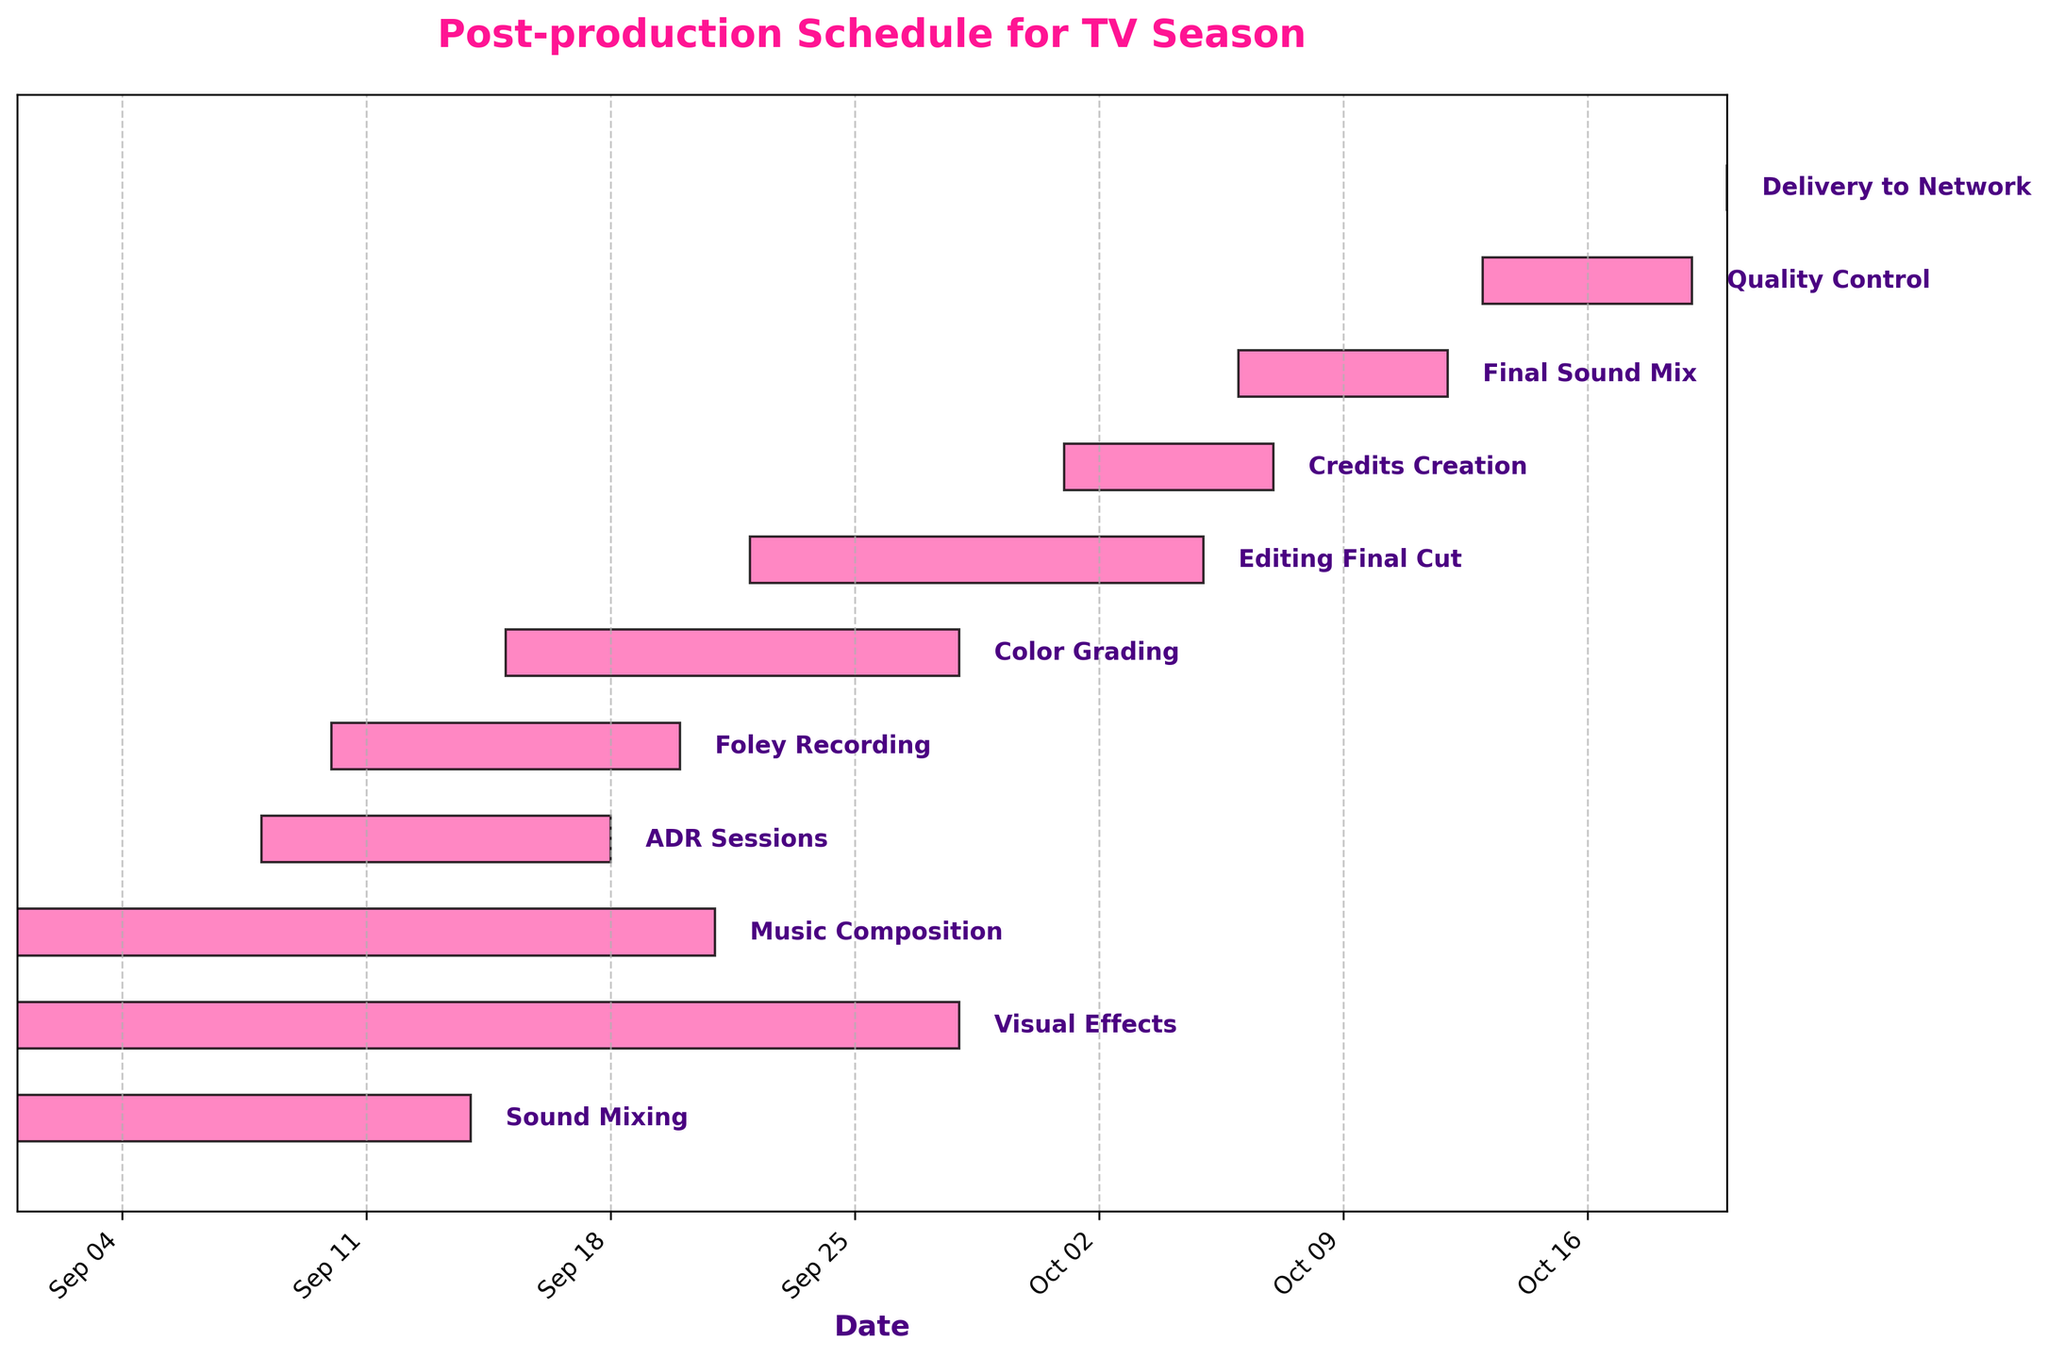What's the title of the Gantt chart? The title is often found at the top of the chart. In this case, it reads "Post-production Schedule for TV Season"
Answer: Post-production Schedule for TV Season What is the first task to start in the schedule? By examining the tasks and their respective start dates, we can see that "Sound Mixing," "Visual Effects," and "Music Composition" all begin on the earliest start date, which is 2023-09-01
Answer: Sound Mixing, Visual Effects, Music Composition Which task ends last in the schedule? To identify the task that ends last, we check the end dates for all tasks. The latest end date is 2023-10-20 for the "Delivery to Network" task
Answer: Delivery to Network What is the duration of the "Editing Final Cut" task? The duration of a task is calculated by the difference between its end date and start date. For "Editing Final Cut," it starts on 2023-09-22 and ends on 2023-10-05. The duration is (2023-10-05 - 2023-09-22) days
Answer: 13 days How many tasks overlap with the "Color Grading" activity? We identify tasks that fall within the start (2023-09-15) and end (2023-09-28) dates of "Color Grading." The overlapping tasks are "Visual Effects," "Music Composition," "ADR Sessions," and "Foley Recording"
Answer: 4 tasks Does "Final Sound Mix" start before or after "Credits Creation" ends? The start and end dates of both tasks need to be compared. "Credits Creation" runs from 2023-10-01 to 2023-10-07, while "Final Sound Mix" starts on 2023-10-06. Since "Final Sound Mix" starts before "Credits Creation" ends
Answer: Before Which task has the shortest duration? To determine the shortest duration, calculate the difference between start and end dates for each task. "Delivery to Network" has the shortest duration, lasting just one day on 2023-10-20
Answer: Delivery to Network List all tasks that start in October. By checking the start dates, only tasks starting on or after October 1, 2023, are considered. These tasks are "Credits Creation" starting on 2023-10-01, "Final Sound Mix" on 2023-10-06, "Quality Control" on 2023-10-13, and "Delivery to Network" on 2023-10-20
Answer: Credits Creation, Final Sound Mix, Quality Control, Delivery to Network Which comes first: "ADR Sessions" or "Foley Recording"? Compare the start dates of both tasks, with "ADR Sessions" starting on 2023-09-08 and "Foley Recording" starting on 2023-09-10. "ADR Sessions" starts earlier
Answer: ADR Sessions How many tasks have a duration of more than two weeks? Tasks with durations exceeding 14 days include "Visual Effects" (27 days), "Music Composition" (20 days), "Editing Final Cut" (13 days), and "Final Sound Mix" (7 days). Note that durations need to be considered in terms of calendar days
Answer: 3 tasks 